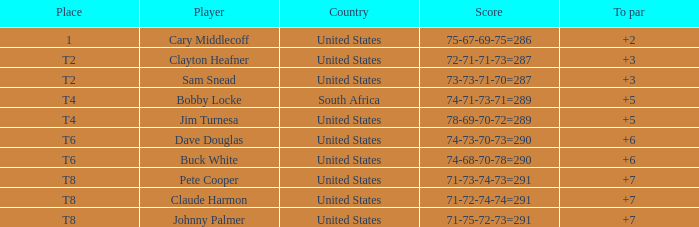What Country is Player Sam Snead with a To par of less than 5 from? United States. 